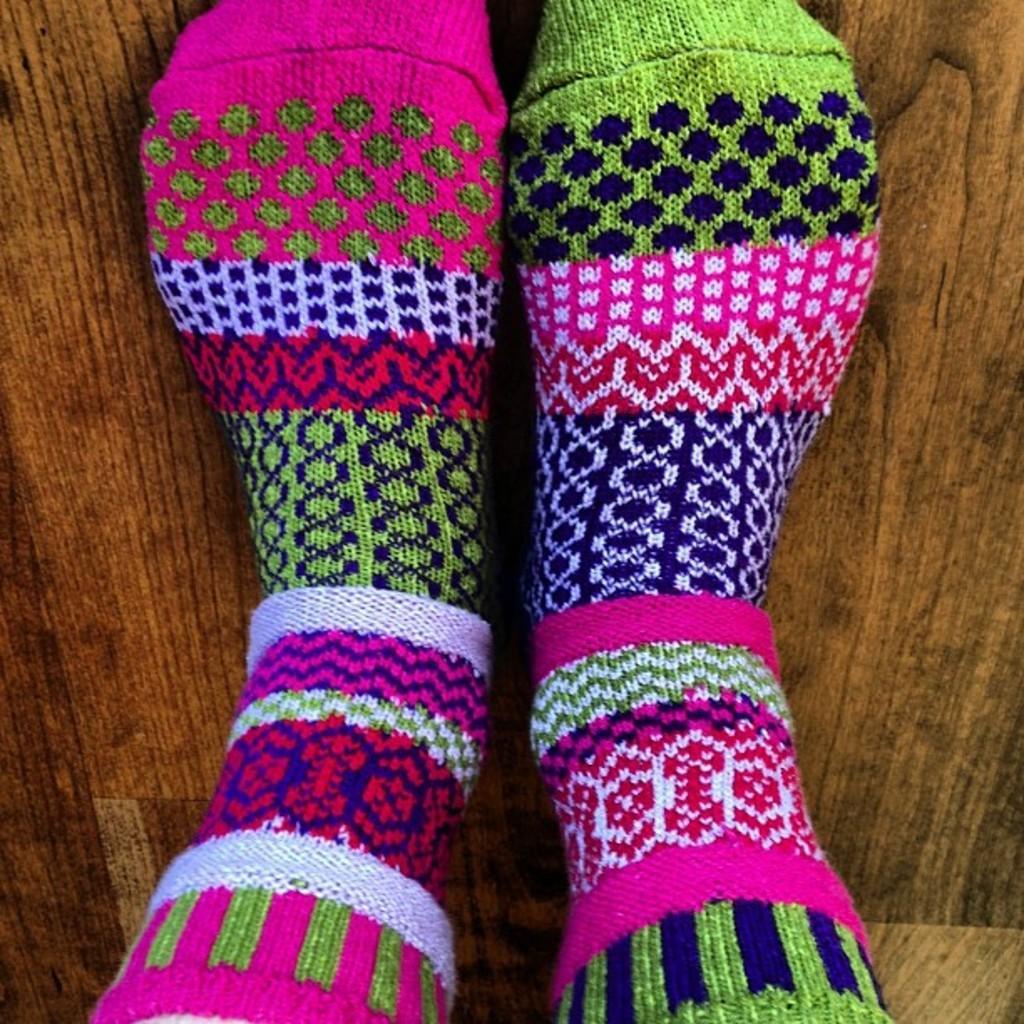Can you describe this image briefly? In the image we can see the socks in multi colors and here we can see wooden surface. 